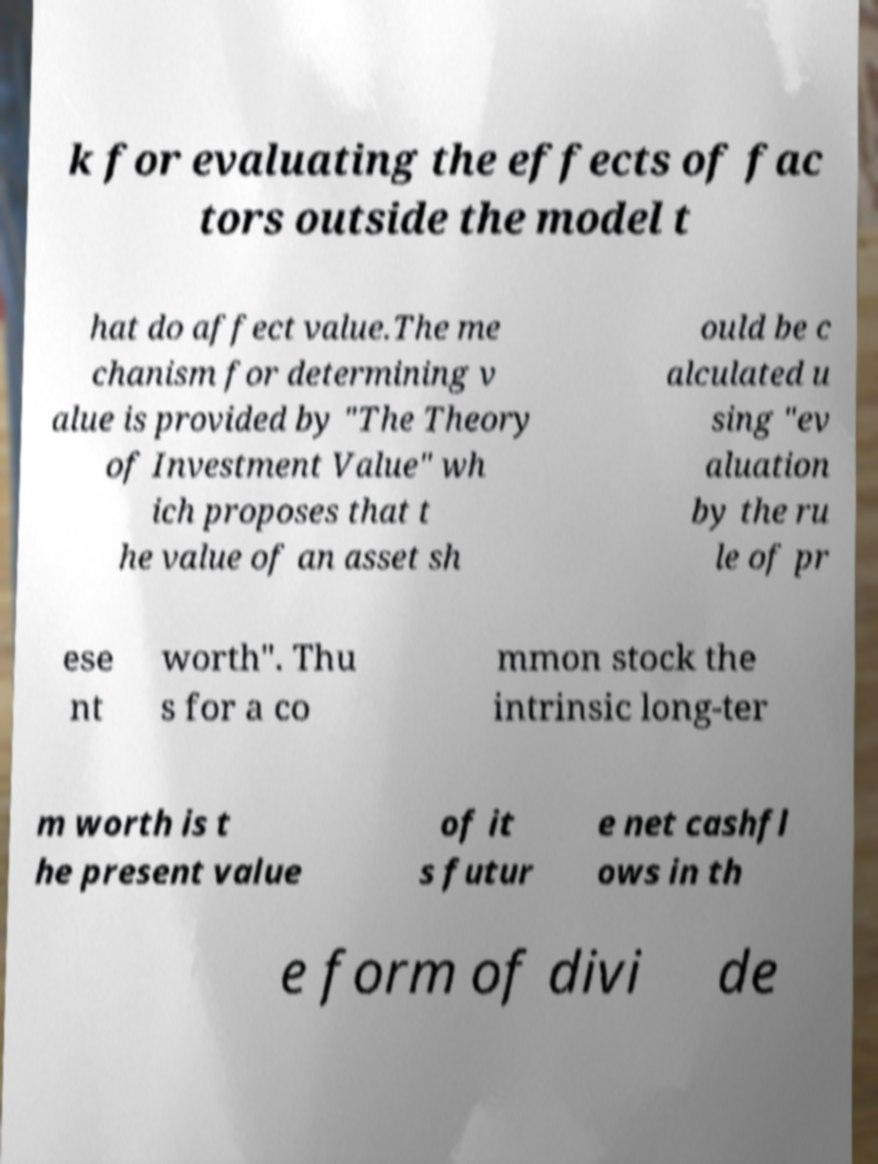Please identify and transcribe the text found in this image. k for evaluating the effects of fac tors outside the model t hat do affect value.The me chanism for determining v alue is provided by "The Theory of Investment Value" wh ich proposes that t he value of an asset sh ould be c alculated u sing "ev aluation by the ru le of pr ese nt worth". Thu s for a co mmon stock the intrinsic long-ter m worth is t he present value of it s futur e net cashfl ows in th e form of divi de 